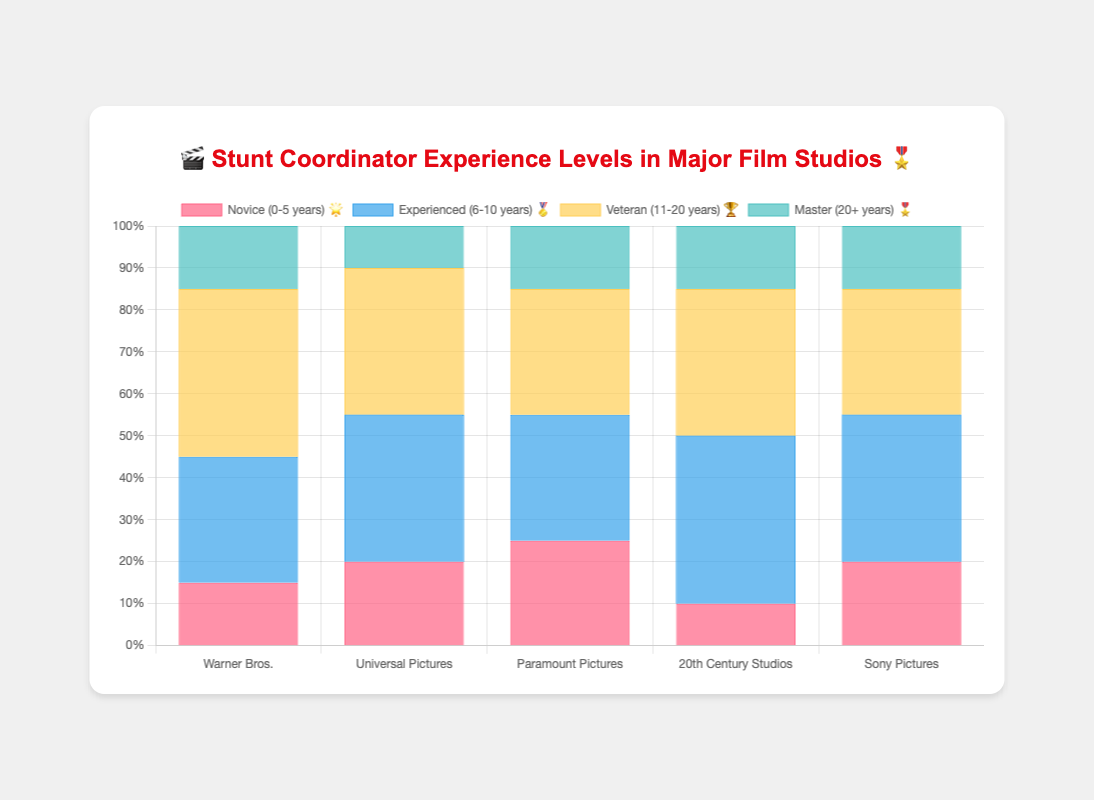What's the total number of Veteran stunt coordinators at Warner Bros. and Universal Pictures according to the chart? To find the total number of Veteran stunt coordinators, we sum the Veterans at Warner Bros. and Universal Pictures: Warner Bros. has 40 Veterans, and Universal Pictures has 35. So, the total is 40 + 35.
Answer: 75 Which studio has the highest number of Novice stunt coordinators? By comparing the number of Novice stunt coordinators across all studios, we see that Paramount Pictures has the highest with 25.
Answer: Paramount Pictures What's the difference in the percentage of Master stunt coordinators between Universal Pictures and Sony Pictures? Universal Pictures has 10% Masters, and Sony Pictures has 15% Masters. The difference is 15% - 10%, which equals 5%.
Answer: 5% Which studio has the most balanced distribution of stunt coordinator experience levels? Comparing the experience levels of each studio, all studios have varying numbers, but Universal Pictures and Sony Pictures have distributions closer to one another across categories, with less dramatic differences in numbers. Thus, they can be considered the most balanced.
Answer: Universal Pictures and Sony Pictures How does the percentage of Experienced (6-10 years) stunt coordinators at 20th Century Studios compare with the percentage at Warner Bros.? 20th Century Studios has 40% Experienced stunt coordinators, while Warner Bros. has 30%. 20th Century Studios has a higher percentage.
Answer: 20th Century Studios has a higher percentage How many more Veteran stunt coordinators are at Warner Bros. compared to Sony Pictures? Warner Bros. has 40 Veterans and Sony Pictures has 30. The difference is 40 - 30, which equals 10.
Answer: 10 Which studio has the least number of Master (20+ years) stunt coordinators? By comparing the Master category across studios, Universal Pictures has the least with only 10.
Answer: Universal Pictures 